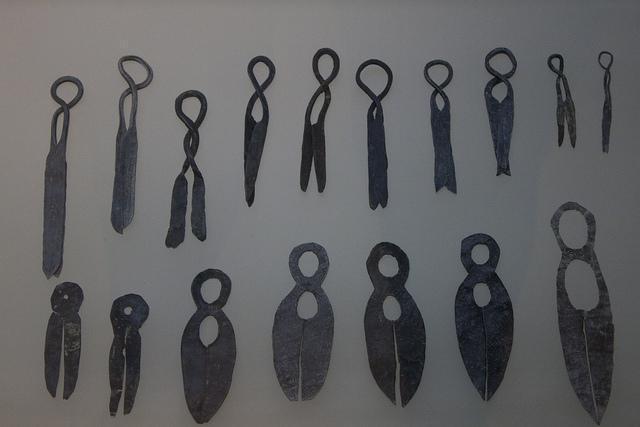How many scissors are in the photo?
Give a very brief answer. 13. 